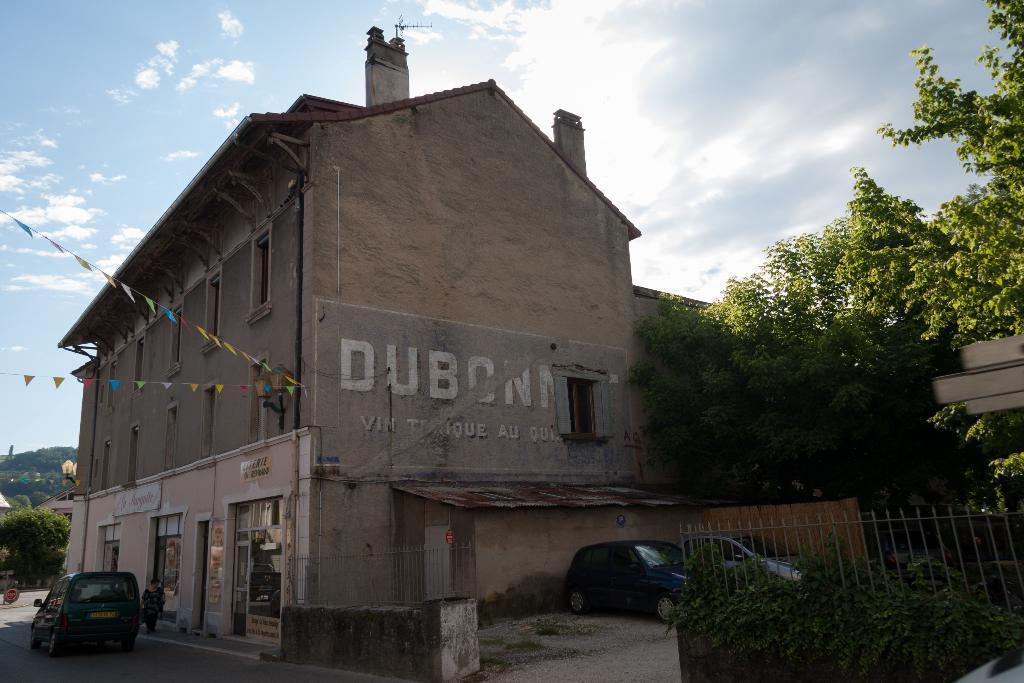Describe this image in one or two sentences. At the bottom of the image there are some plants and fencing and vehicles and a woman is walking. in the middle of the image there are some trees and buildings. At the top of the image there are some clouds and sky. 